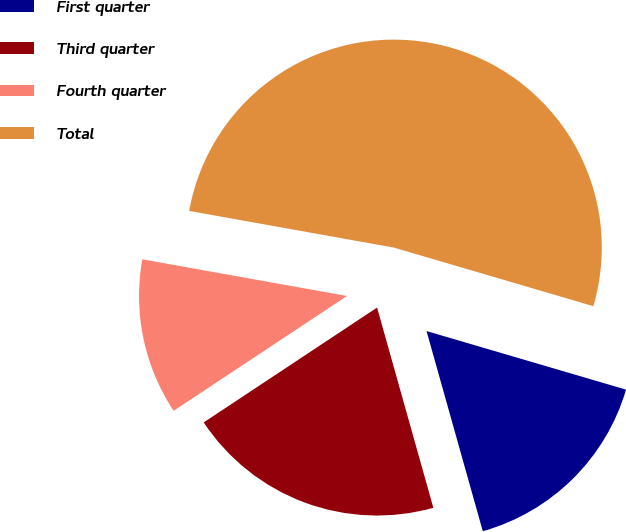<chart> <loc_0><loc_0><loc_500><loc_500><pie_chart><fcel>First quarter<fcel>Third quarter<fcel>Fourth quarter<fcel>Total<nl><fcel>16.09%<fcel>20.05%<fcel>12.13%<fcel>51.72%<nl></chart> 